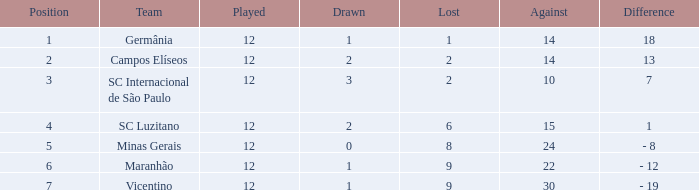What distinction has a score exceeding 10, and a tie below 2? 18.0. 